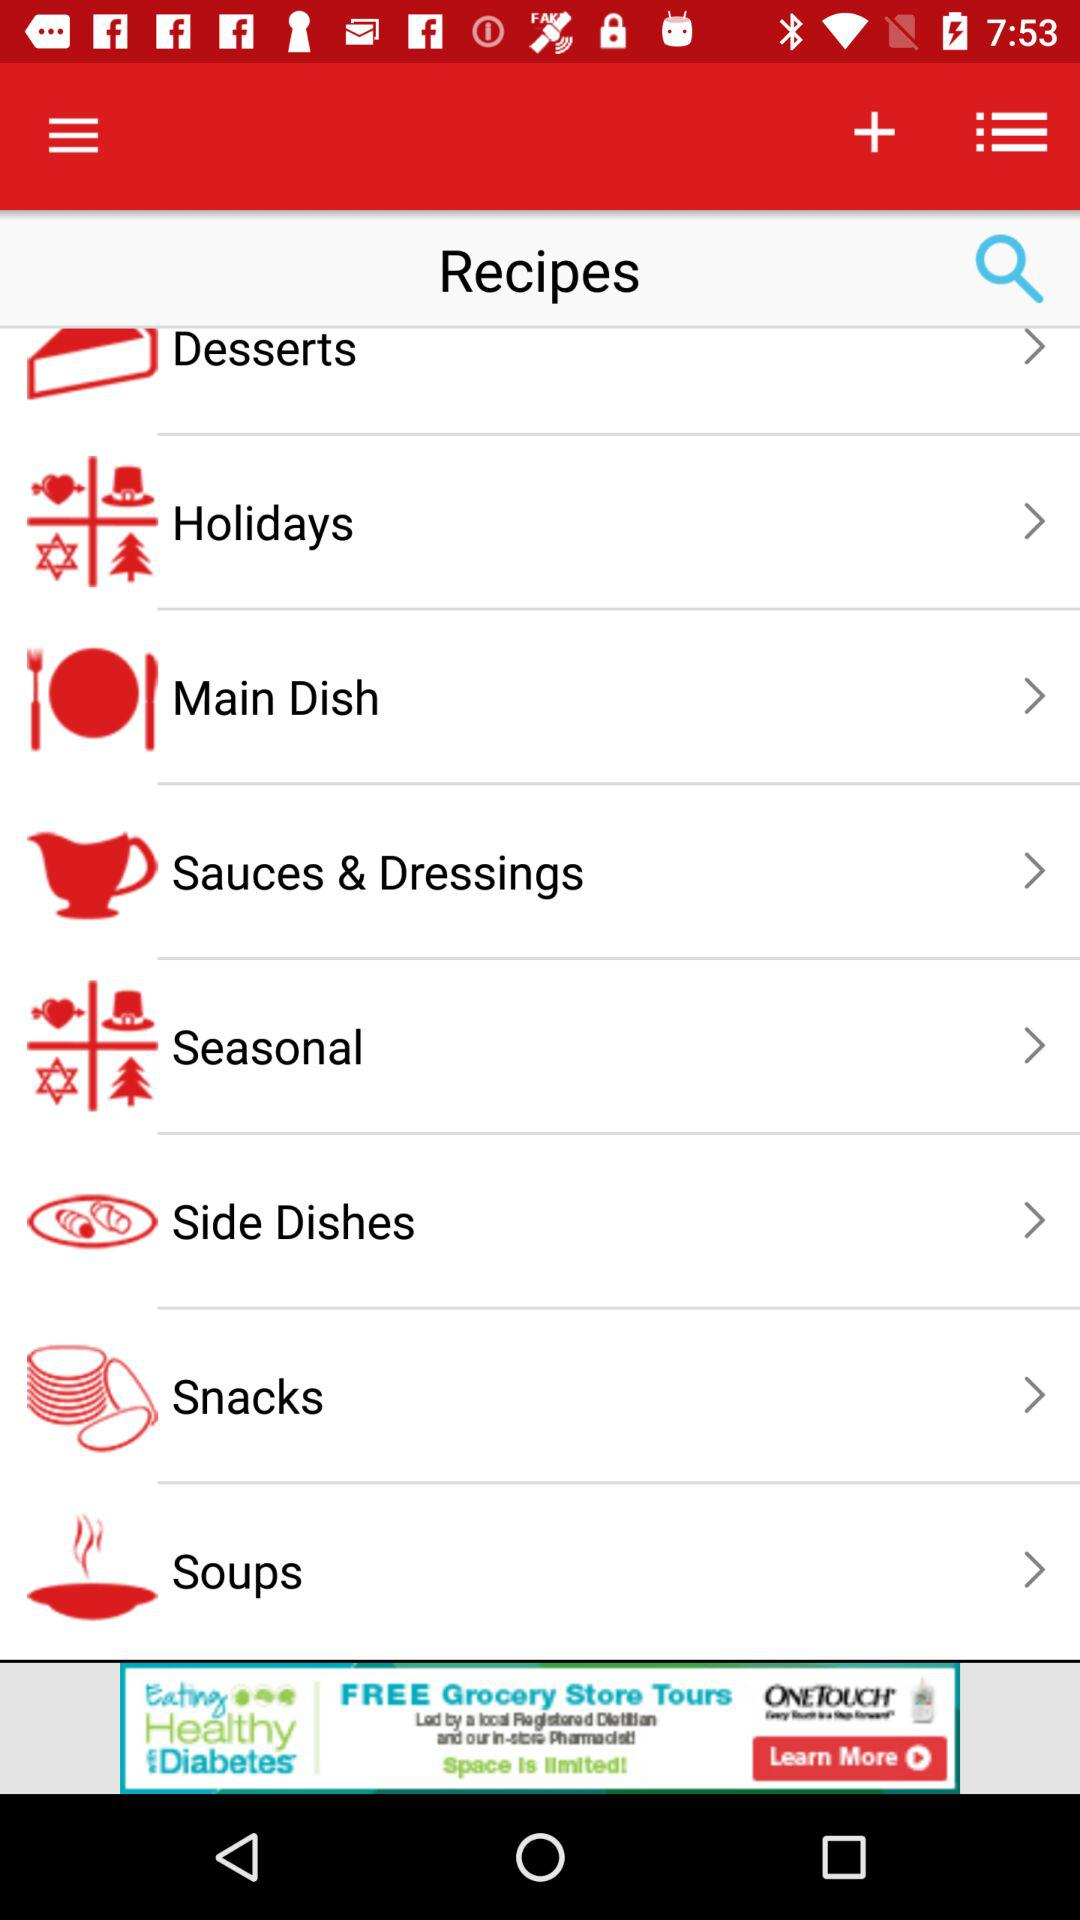What is the list of available recipes? The available recipes are "Desserts", "Holidays", "Main Dish", "Sauces & Dressings", "Seasonal", "Side Dishes", "Snacks" and "Soups". 